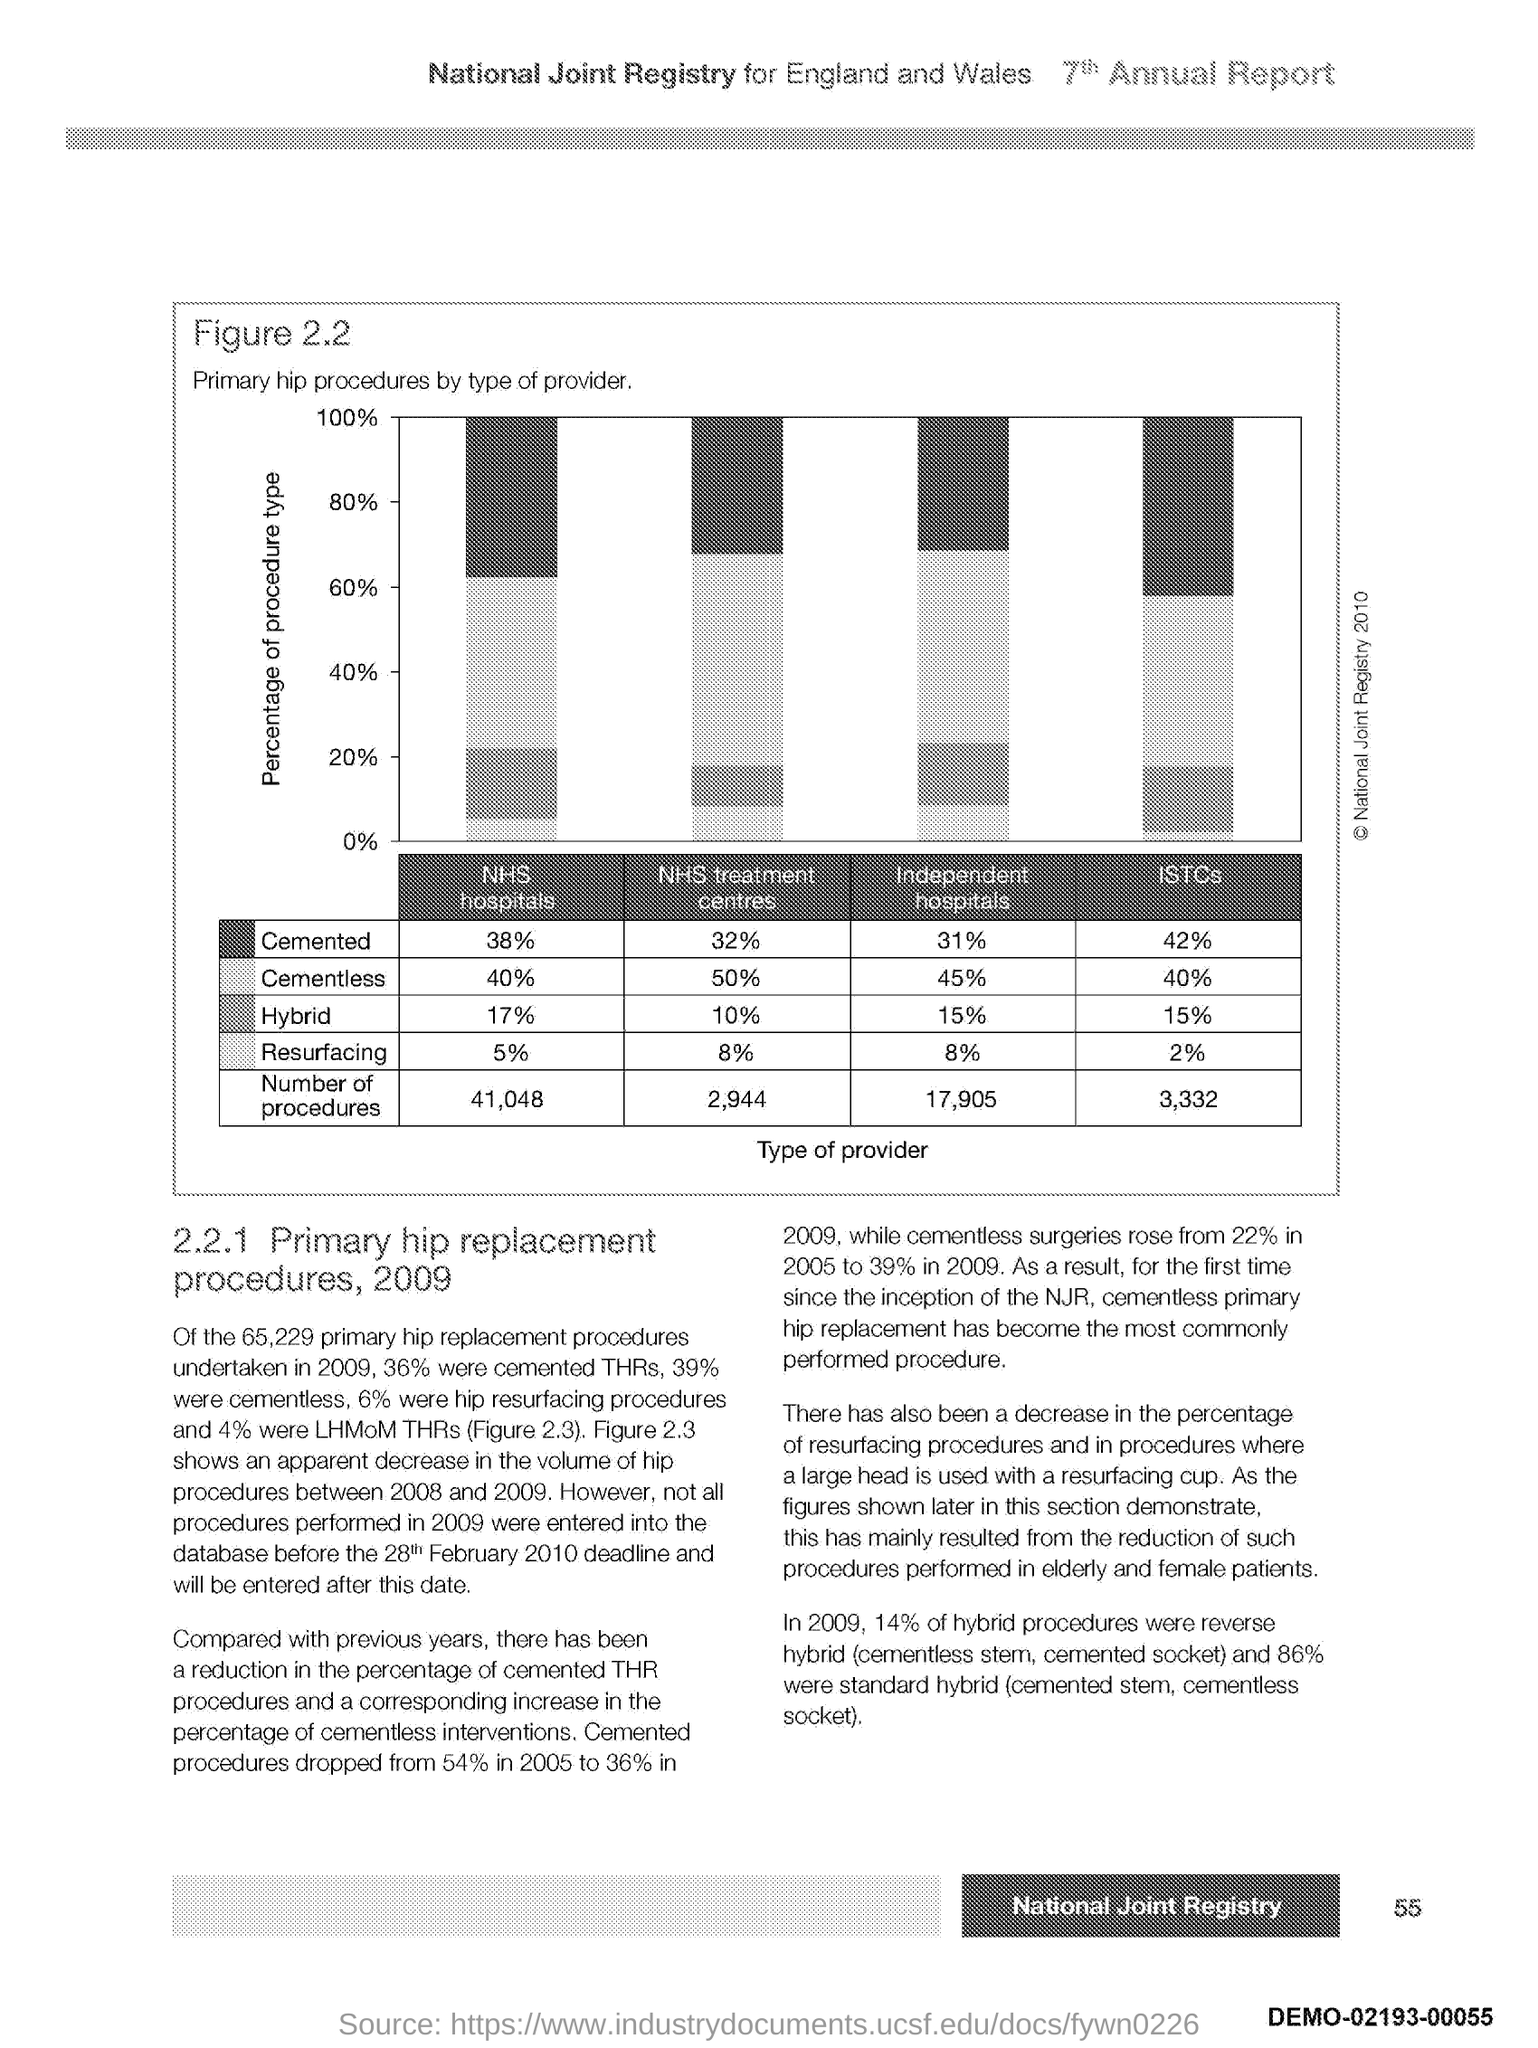What is plotted in the y-axis?
Ensure brevity in your answer.  Percentage of procedure type. 